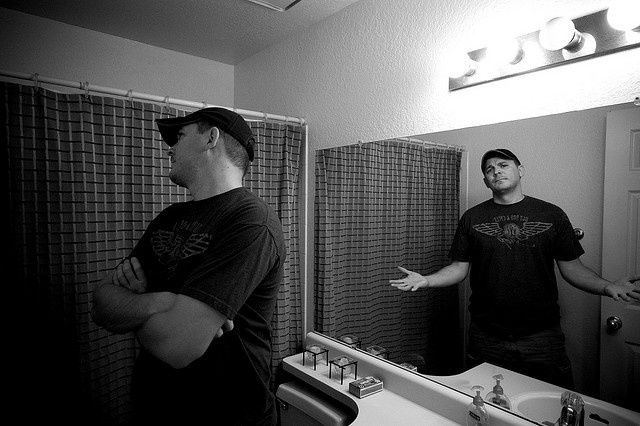Describe the objects in this image and their specific colors. I can see people in black, gray, darkgray, and lightgray tones, people in black, gray, darkgray, and lightgray tones, sink in black, darkgray, gray, and lightgray tones, and toilet in black and gray tones in this image. 